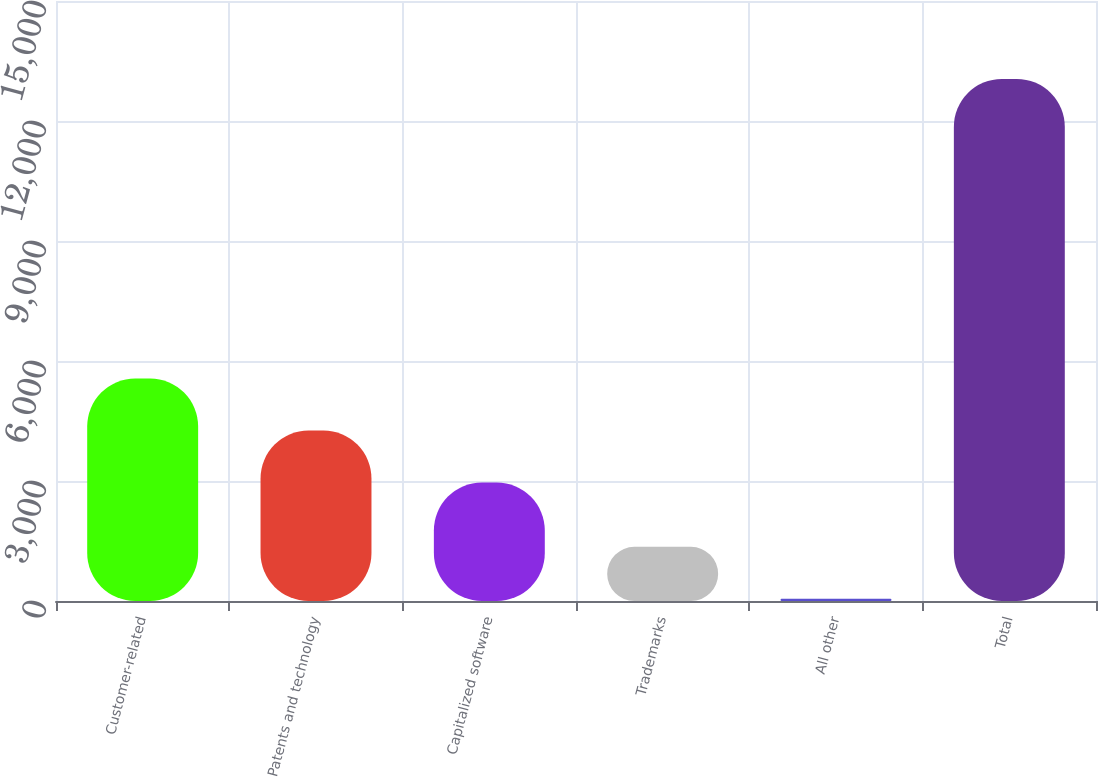Convert chart to OTSL. <chart><loc_0><loc_0><loc_500><loc_500><bar_chart><fcel>Customer-related<fcel>Patents and technology<fcel>Capitalized software<fcel>Trademarks<fcel>All other<fcel>Total<nl><fcel>5561.6<fcel>4261.8<fcel>2962<fcel>1353.8<fcel>54<fcel>13052<nl></chart> 